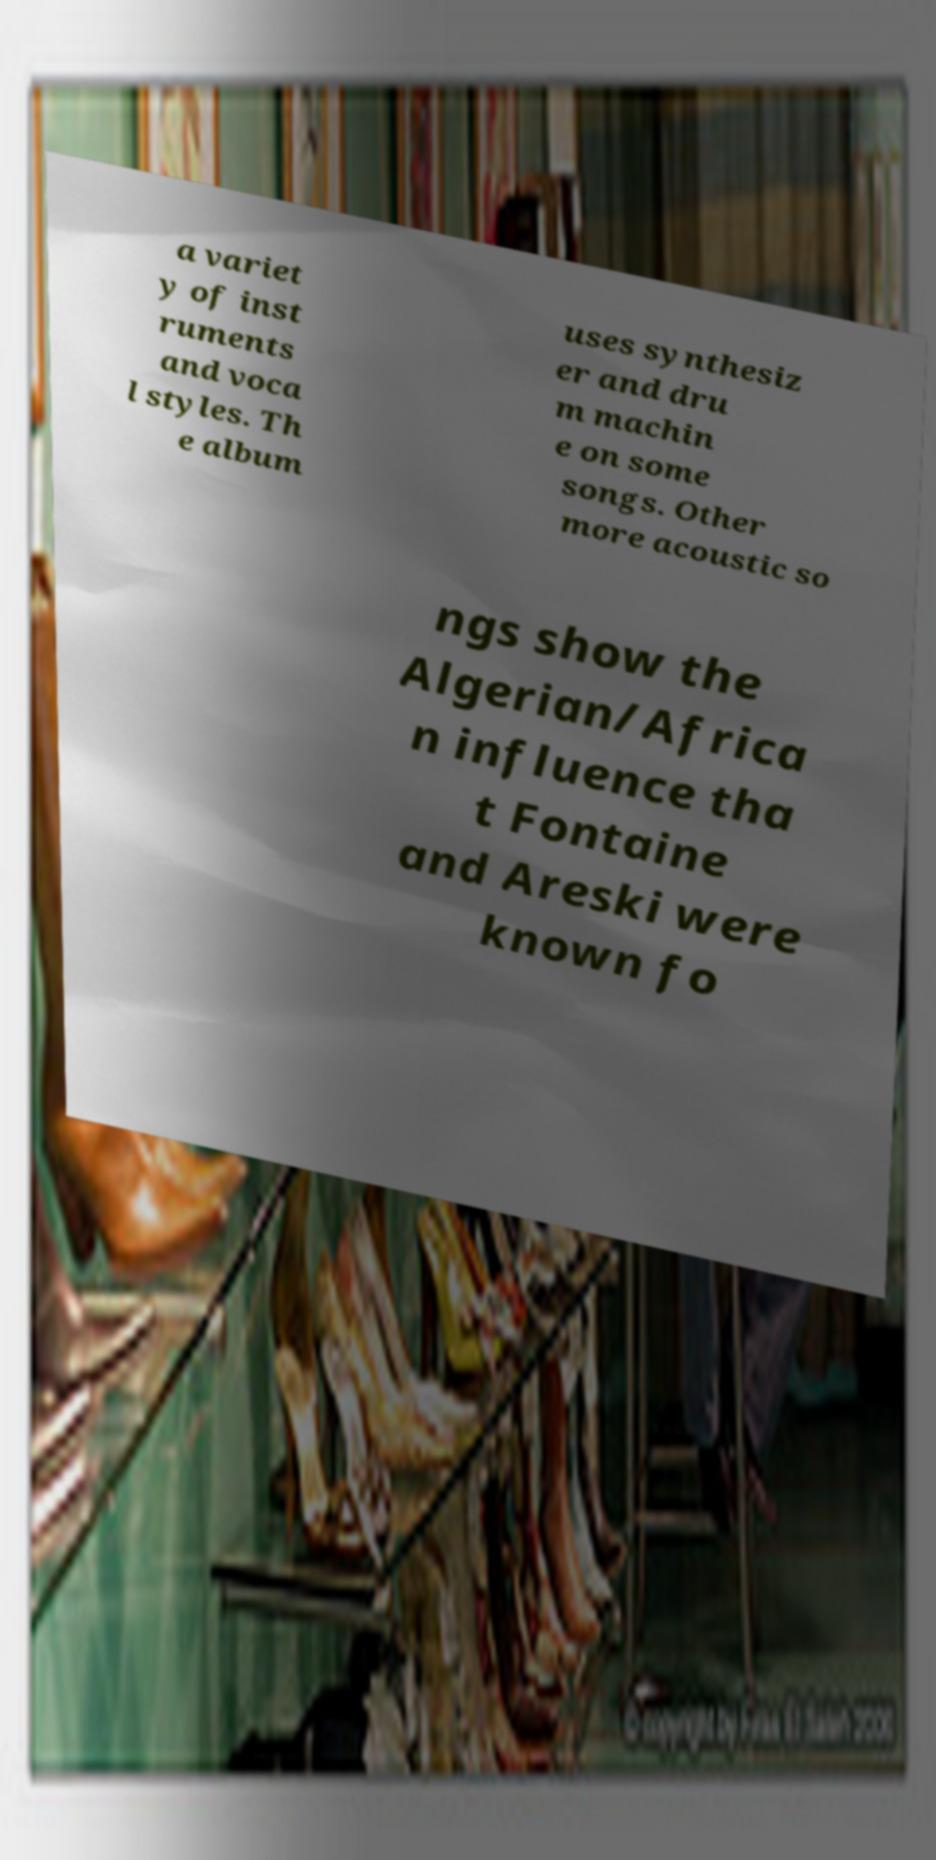Could you assist in decoding the text presented in this image and type it out clearly? a variet y of inst ruments and voca l styles. Th e album uses synthesiz er and dru m machin e on some songs. Other more acoustic so ngs show the Algerian/Africa n influence tha t Fontaine and Areski were known fo 